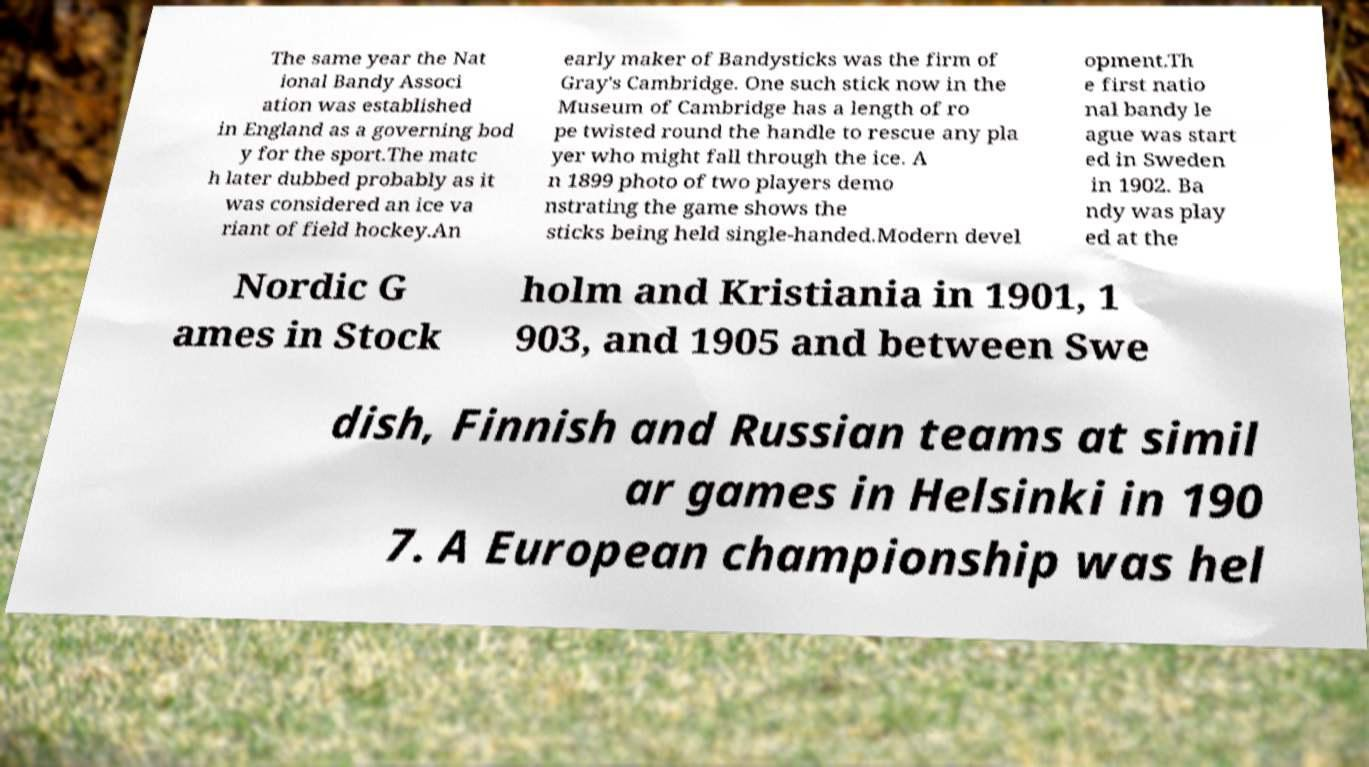For documentation purposes, I need the text within this image transcribed. Could you provide that? The same year the Nat ional Bandy Associ ation was established in England as a governing bod y for the sport.The matc h later dubbed probably as it was considered an ice va riant of field hockey.An early maker of Bandysticks was the firm of Gray's Cambridge. One such stick now in the Museum of Cambridge has a length of ro pe twisted round the handle to rescue any pla yer who might fall through the ice. A n 1899 photo of two players demo nstrating the game shows the sticks being held single-handed.Modern devel opment.Th e first natio nal bandy le ague was start ed in Sweden in 1902. Ba ndy was play ed at the Nordic G ames in Stock holm and Kristiania in 1901, 1 903, and 1905 and between Swe dish, Finnish and Russian teams at simil ar games in Helsinki in 190 7. A European championship was hel 